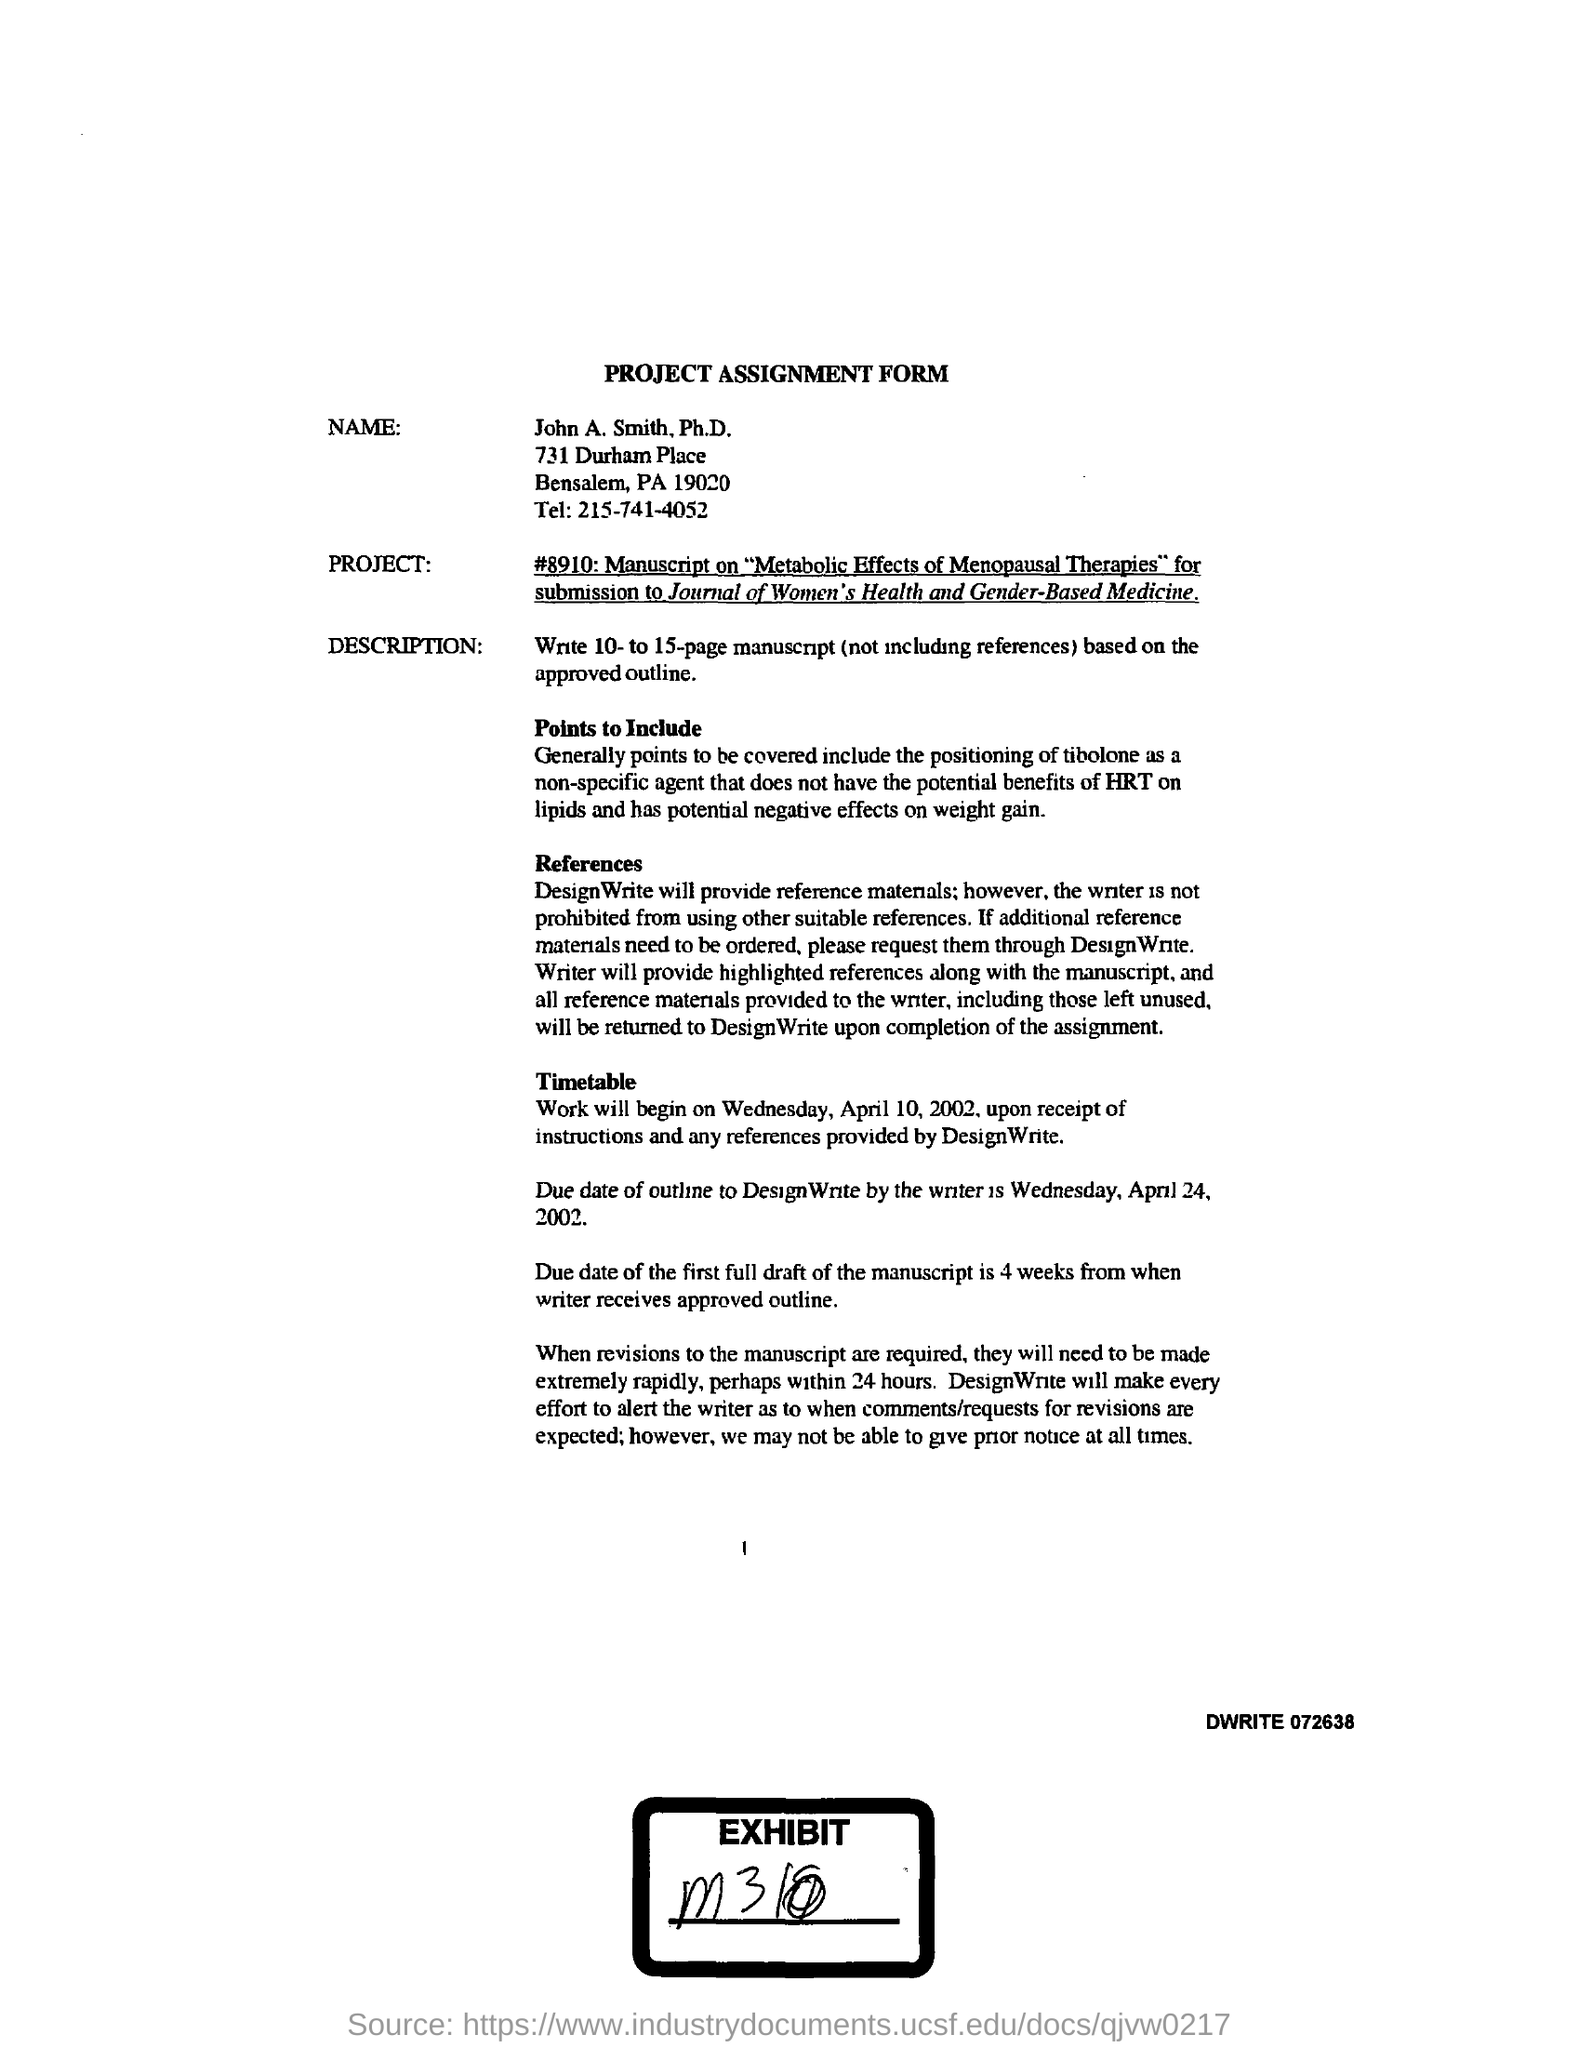What form is this
Your response must be concise. PROJECT ASSIGNMENT FORM. What is the telephone no given by John A. Smith,Ph.D,
Offer a very short reply. 215-741-4052. 